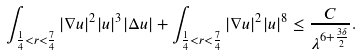<formula> <loc_0><loc_0><loc_500><loc_500>\int _ { \frac { 1 } { 4 } < r < \frac { 7 } { 4 } } | \nabla u | ^ { 2 } | u | ^ { 3 } | \Delta u | + \int _ { \frac { 1 } { 4 } < r < \frac { 7 } { 4 } } | \nabla u | ^ { 2 } | u | ^ { 8 } \leq \frac { C } { \lambda ^ { 6 + \frac { 3 \delta } { 2 } } } .</formula> 